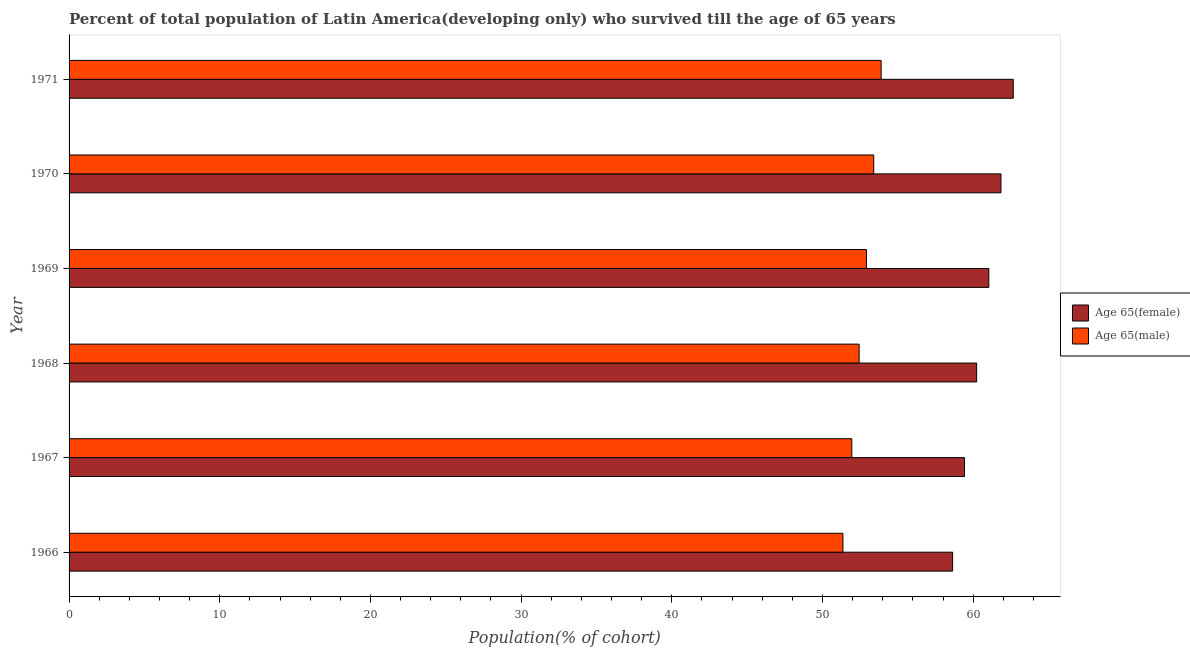How many groups of bars are there?
Your answer should be very brief. 6. Are the number of bars per tick equal to the number of legend labels?
Keep it short and to the point. Yes. How many bars are there on the 1st tick from the bottom?
Keep it short and to the point. 2. What is the label of the 3rd group of bars from the top?
Your response must be concise. 1969. What is the percentage of female population who survived till age of 65 in 1971?
Your response must be concise. 62.66. Across all years, what is the maximum percentage of female population who survived till age of 65?
Give a very brief answer. 62.66. Across all years, what is the minimum percentage of male population who survived till age of 65?
Ensure brevity in your answer.  51.36. In which year was the percentage of female population who survived till age of 65 minimum?
Your response must be concise. 1966. What is the total percentage of male population who survived till age of 65 in the graph?
Provide a short and direct response. 315.94. What is the difference between the percentage of male population who survived till age of 65 in 1966 and that in 1967?
Your answer should be compact. -0.59. What is the difference between the percentage of female population who survived till age of 65 in 1967 and the percentage of male population who survived till age of 65 in 1969?
Your answer should be compact. 6.5. What is the average percentage of male population who survived till age of 65 per year?
Ensure brevity in your answer.  52.66. In the year 1966, what is the difference between the percentage of male population who survived till age of 65 and percentage of female population who survived till age of 65?
Ensure brevity in your answer.  -7.28. Is the percentage of female population who survived till age of 65 in 1966 less than that in 1967?
Make the answer very short. Yes. What is the difference between the highest and the second highest percentage of male population who survived till age of 65?
Your answer should be very brief. 0.49. What is the difference between the highest and the lowest percentage of female population who survived till age of 65?
Give a very brief answer. 4.02. In how many years, is the percentage of male population who survived till age of 65 greater than the average percentage of male population who survived till age of 65 taken over all years?
Your answer should be very brief. 3. What does the 1st bar from the top in 1969 represents?
Your answer should be compact. Age 65(male). What does the 2nd bar from the bottom in 1969 represents?
Provide a succinct answer. Age 65(male). How many bars are there?
Offer a very short reply. 12. What is the difference between two consecutive major ticks on the X-axis?
Your response must be concise. 10. How many legend labels are there?
Your answer should be compact. 2. How are the legend labels stacked?
Your answer should be very brief. Vertical. What is the title of the graph?
Offer a terse response. Percent of total population of Latin America(developing only) who survived till the age of 65 years. Does "Young" appear as one of the legend labels in the graph?
Give a very brief answer. No. What is the label or title of the X-axis?
Keep it short and to the point. Population(% of cohort). What is the label or title of the Y-axis?
Your answer should be compact. Year. What is the Population(% of cohort) of Age 65(female) in 1966?
Make the answer very short. 58.64. What is the Population(% of cohort) in Age 65(male) in 1966?
Offer a very short reply. 51.36. What is the Population(% of cohort) in Age 65(female) in 1967?
Keep it short and to the point. 59.42. What is the Population(% of cohort) in Age 65(male) in 1967?
Make the answer very short. 51.94. What is the Population(% of cohort) of Age 65(female) in 1968?
Provide a short and direct response. 60.23. What is the Population(% of cohort) of Age 65(male) in 1968?
Provide a short and direct response. 52.43. What is the Population(% of cohort) in Age 65(female) in 1969?
Your answer should be very brief. 61.04. What is the Population(% of cohort) in Age 65(male) in 1969?
Provide a succinct answer. 52.92. What is the Population(% of cohort) of Age 65(female) in 1970?
Make the answer very short. 61.84. What is the Population(% of cohort) in Age 65(male) in 1970?
Give a very brief answer. 53.4. What is the Population(% of cohort) in Age 65(female) in 1971?
Keep it short and to the point. 62.66. What is the Population(% of cohort) in Age 65(male) in 1971?
Your response must be concise. 53.89. Across all years, what is the maximum Population(% of cohort) of Age 65(female)?
Make the answer very short. 62.66. Across all years, what is the maximum Population(% of cohort) of Age 65(male)?
Give a very brief answer. 53.89. Across all years, what is the minimum Population(% of cohort) in Age 65(female)?
Your answer should be compact. 58.64. Across all years, what is the minimum Population(% of cohort) of Age 65(male)?
Keep it short and to the point. 51.36. What is the total Population(% of cohort) in Age 65(female) in the graph?
Your answer should be very brief. 363.83. What is the total Population(% of cohort) of Age 65(male) in the graph?
Make the answer very short. 315.94. What is the difference between the Population(% of cohort) of Age 65(female) in 1966 and that in 1967?
Make the answer very short. -0.79. What is the difference between the Population(% of cohort) of Age 65(male) in 1966 and that in 1967?
Offer a very short reply. -0.59. What is the difference between the Population(% of cohort) in Age 65(female) in 1966 and that in 1968?
Offer a terse response. -1.6. What is the difference between the Population(% of cohort) of Age 65(male) in 1966 and that in 1968?
Provide a short and direct response. -1.07. What is the difference between the Population(% of cohort) of Age 65(female) in 1966 and that in 1969?
Offer a very short reply. -2.4. What is the difference between the Population(% of cohort) of Age 65(male) in 1966 and that in 1969?
Keep it short and to the point. -1.56. What is the difference between the Population(% of cohort) of Age 65(female) in 1966 and that in 1970?
Give a very brief answer. -3.21. What is the difference between the Population(% of cohort) of Age 65(male) in 1966 and that in 1970?
Your answer should be compact. -2.04. What is the difference between the Population(% of cohort) of Age 65(female) in 1966 and that in 1971?
Offer a terse response. -4.02. What is the difference between the Population(% of cohort) in Age 65(male) in 1966 and that in 1971?
Keep it short and to the point. -2.53. What is the difference between the Population(% of cohort) of Age 65(female) in 1967 and that in 1968?
Keep it short and to the point. -0.81. What is the difference between the Population(% of cohort) in Age 65(male) in 1967 and that in 1968?
Keep it short and to the point. -0.49. What is the difference between the Population(% of cohort) in Age 65(female) in 1967 and that in 1969?
Your response must be concise. -1.62. What is the difference between the Population(% of cohort) in Age 65(male) in 1967 and that in 1969?
Give a very brief answer. -0.97. What is the difference between the Population(% of cohort) in Age 65(female) in 1967 and that in 1970?
Provide a succinct answer. -2.42. What is the difference between the Population(% of cohort) of Age 65(male) in 1967 and that in 1970?
Ensure brevity in your answer.  -1.46. What is the difference between the Population(% of cohort) in Age 65(female) in 1967 and that in 1971?
Ensure brevity in your answer.  -3.24. What is the difference between the Population(% of cohort) in Age 65(male) in 1967 and that in 1971?
Your response must be concise. -1.95. What is the difference between the Population(% of cohort) in Age 65(female) in 1968 and that in 1969?
Provide a short and direct response. -0.81. What is the difference between the Population(% of cohort) in Age 65(male) in 1968 and that in 1969?
Give a very brief answer. -0.49. What is the difference between the Population(% of cohort) of Age 65(female) in 1968 and that in 1970?
Offer a terse response. -1.61. What is the difference between the Population(% of cohort) of Age 65(male) in 1968 and that in 1970?
Provide a short and direct response. -0.97. What is the difference between the Population(% of cohort) of Age 65(female) in 1968 and that in 1971?
Keep it short and to the point. -2.43. What is the difference between the Population(% of cohort) in Age 65(male) in 1968 and that in 1971?
Give a very brief answer. -1.46. What is the difference between the Population(% of cohort) of Age 65(female) in 1969 and that in 1970?
Offer a very short reply. -0.81. What is the difference between the Population(% of cohort) of Age 65(male) in 1969 and that in 1970?
Provide a succinct answer. -0.48. What is the difference between the Population(% of cohort) in Age 65(female) in 1969 and that in 1971?
Give a very brief answer. -1.62. What is the difference between the Population(% of cohort) of Age 65(male) in 1969 and that in 1971?
Your response must be concise. -0.97. What is the difference between the Population(% of cohort) of Age 65(female) in 1970 and that in 1971?
Make the answer very short. -0.82. What is the difference between the Population(% of cohort) in Age 65(male) in 1970 and that in 1971?
Offer a terse response. -0.49. What is the difference between the Population(% of cohort) of Age 65(female) in 1966 and the Population(% of cohort) of Age 65(male) in 1967?
Your answer should be very brief. 6.69. What is the difference between the Population(% of cohort) in Age 65(female) in 1966 and the Population(% of cohort) in Age 65(male) in 1968?
Your answer should be compact. 6.2. What is the difference between the Population(% of cohort) in Age 65(female) in 1966 and the Population(% of cohort) in Age 65(male) in 1969?
Make the answer very short. 5.72. What is the difference between the Population(% of cohort) of Age 65(female) in 1966 and the Population(% of cohort) of Age 65(male) in 1970?
Provide a short and direct response. 5.23. What is the difference between the Population(% of cohort) in Age 65(female) in 1966 and the Population(% of cohort) in Age 65(male) in 1971?
Keep it short and to the point. 4.74. What is the difference between the Population(% of cohort) of Age 65(female) in 1967 and the Population(% of cohort) of Age 65(male) in 1968?
Offer a very short reply. 6.99. What is the difference between the Population(% of cohort) in Age 65(female) in 1967 and the Population(% of cohort) in Age 65(male) in 1969?
Make the answer very short. 6.5. What is the difference between the Population(% of cohort) of Age 65(female) in 1967 and the Population(% of cohort) of Age 65(male) in 1970?
Provide a short and direct response. 6.02. What is the difference between the Population(% of cohort) in Age 65(female) in 1967 and the Population(% of cohort) in Age 65(male) in 1971?
Make the answer very short. 5.53. What is the difference between the Population(% of cohort) of Age 65(female) in 1968 and the Population(% of cohort) of Age 65(male) in 1969?
Your response must be concise. 7.31. What is the difference between the Population(% of cohort) of Age 65(female) in 1968 and the Population(% of cohort) of Age 65(male) in 1970?
Your response must be concise. 6.83. What is the difference between the Population(% of cohort) in Age 65(female) in 1968 and the Population(% of cohort) in Age 65(male) in 1971?
Provide a succinct answer. 6.34. What is the difference between the Population(% of cohort) of Age 65(female) in 1969 and the Population(% of cohort) of Age 65(male) in 1970?
Offer a very short reply. 7.64. What is the difference between the Population(% of cohort) of Age 65(female) in 1969 and the Population(% of cohort) of Age 65(male) in 1971?
Provide a short and direct response. 7.15. What is the difference between the Population(% of cohort) of Age 65(female) in 1970 and the Population(% of cohort) of Age 65(male) in 1971?
Keep it short and to the point. 7.95. What is the average Population(% of cohort) in Age 65(female) per year?
Your answer should be very brief. 60.64. What is the average Population(% of cohort) of Age 65(male) per year?
Keep it short and to the point. 52.66. In the year 1966, what is the difference between the Population(% of cohort) of Age 65(female) and Population(% of cohort) of Age 65(male)?
Your answer should be very brief. 7.28. In the year 1967, what is the difference between the Population(% of cohort) of Age 65(female) and Population(% of cohort) of Age 65(male)?
Ensure brevity in your answer.  7.48. In the year 1968, what is the difference between the Population(% of cohort) of Age 65(female) and Population(% of cohort) of Age 65(male)?
Keep it short and to the point. 7.8. In the year 1969, what is the difference between the Population(% of cohort) of Age 65(female) and Population(% of cohort) of Age 65(male)?
Your answer should be compact. 8.12. In the year 1970, what is the difference between the Population(% of cohort) in Age 65(female) and Population(% of cohort) in Age 65(male)?
Offer a terse response. 8.44. In the year 1971, what is the difference between the Population(% of cohort) in Age 65(female) and Population(% of cohort) in Age 65(male)?
Your response must be concise. 8.77. What is the ratio of the Population(% of cohort) of Age 65(female) in 1966 to that in 1967?
Provide a succinct answer. 0.99. What is the ratio of the Population(% of cohort) in Age 65(male) in 1966 to that in 1967?
Give a very brief answer. 0.99. What is the ratio of the Population(% of cohort) in Age 65(female) in 1966 to that in 1968?
Provide a short and direct response. 0.97. What is the ratio of the Population(% of cohort) of Age 65(male) in 1966 to that in 1968?
Ensure brevity in your answer.  0.98. What is the ratio of the Population(% of cohort) of Age 65(female) in 1966 to that in 1969?
Ensure brevity in your answer.  0.96. What is the ratio of the Population(% of cohort) in Age 65(male) in 1966 to that in 1969?
Provide a short and direct response. 0.97. What is the ratio of the Population(% of cohort) in Age 65(female) in 1966 to that in 1970?
Provide a succinct answer. 0.95. What is the ratio of the Population(% of cohort) of Age 65(male) in 1966 to that in 1970?
Ensure brevity in your answer.  0.96. What is the ratio of the Population(% of cohort) of Age 65(female) in 1966 to that in 1971?
Ensure brevity in your answer.  0.94. What is the ratio of the Population(% of cohort) of Age 65(male) in 1966 to that in 1971?
Provide a succinct answer. 0.95. What is the ratio of the Population(% of cohort) in Age 65(female) in 1967 to that in 1968?
Your answer should be very brief. 0.99. What is the ratio of the Population(% of cohort) in Age 65(female) in 1967 to that in 1969?
Your answer should be compact. 0.97. What is the ratio of the Population(% of cohort) of Age 65(male) in 1967 to that in 1969?
Your answer should be very brief. 0.98. What is the ratio of the Population(% of cohort) of Age 65(female) in 1967 to that in 1970?
Give a very brief answer. 0.96. What is the ratio of the Population(% of cohort) of Age 65(male) in 1967 to that in 1970?
Your response must be concise. 0.97. What is the ratio of the Population(% of cohort) of Age 65(female) in 1967 to that in 1971?
Your answer should be very brief. 0.95. What is the ratio of the Population(% of cohort) in Age 65(male) in 1967 to that in 1971?
Give a very brief answer. 0.96. What is the ratio of the Population(% of cohort) of Age 65(female) in 1968 to that in 1969?
Your answer should be very brief. 0.99. What is the ratio of the Population(% of cohort) of Age 65(female) in 1968 to that in 1970?
Provide a short and direct response. 0.97. What is the ratio of the Population(% of cohort) of Age 65(male) in 1968 to that in 1970?
Provide a succinct answer. 0.98. What is the ratio of the Population(% of cohort) of Age 65(female) in 1968 to that in 1971?
Keep it short and to the point. 0.96. What is the ratio of the Population(% of cohort) of Age 65(male) in 1968 to that in 1971?
Your answer should be very brief. 0.97. What is the ratio of the Population(% of cohort) of Age 65(male) in 1969 to that in 1970?
Keep it short and to the point. 0.99. What is the ratio of the Population(% of cohort) in Age 65(female) in 1969 to that in 1971?
Provide a succinct answer. 0.97. What is the ratio of the Population(% of cohort) of Age 65(male) in 1969 to that in 1971?
Your answer should be compact. 0.98. What is the ratio of the Population(% of cohort) in Age 65(female) in 1970 to that in 1971?
Provide a short and direct response. 0.99. What is the ratio of the Population(% of cohort) of Age 65(male) in 1970 to that in 1971?
Ensure brevity in your answer.  0.99. What is the difference between the highest and the second highest Population(% of cohort) in Age 65(female)?
Offer a very short reply. 0.82. What is the difference between the highest and the second highest Population(% of cohort) of Age 65(male)?
Your answer should be very brief. 0.49. What is the difference between the highest and the lowest Population(% of cohort) of Age 65(female)?
Your answer should be compact. 4.02. What is the difference between the highest and the lowest Population(% of cohort) of Age 65(male)?
Give a very brief answer. 2.53. 